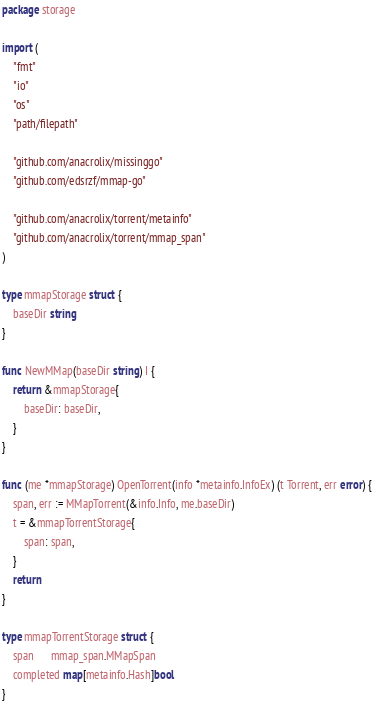Convert code to text. <code><loc_0><loc_0><loc_500><loc_500><_Go_>package storage

import (
	"fmt"
	"io"
	"os"
	"path/filepath"

	"github.com/anacrolix/missinggo"
	"github.com/edsrzf/mmap-go"

	"github.com/anacrolix/torrent/metainfo"
	"github.com/anacrolix/torrent/mmap_span"
)

type mmapStorage struct {
	baseDir string
}

func NewMMap(baseDir string) I {
	return &mmapStorage{
		baseDir: baseDir,
	}
}

func (me *mmapStorage) OpenTorrent(info *metainfo.InfoEx) (t Torrent, err error) {
	span, err := MMapTorrent(&info.Info, me.baseDir)
	t = &mmapTorrentStorage{
		span: span,
	}
	return
}

type mmapTorrentStorage struct {
	span      mmap_span.MMapSpan
	completed map[metainfo.Hash]bool
}
</code> 